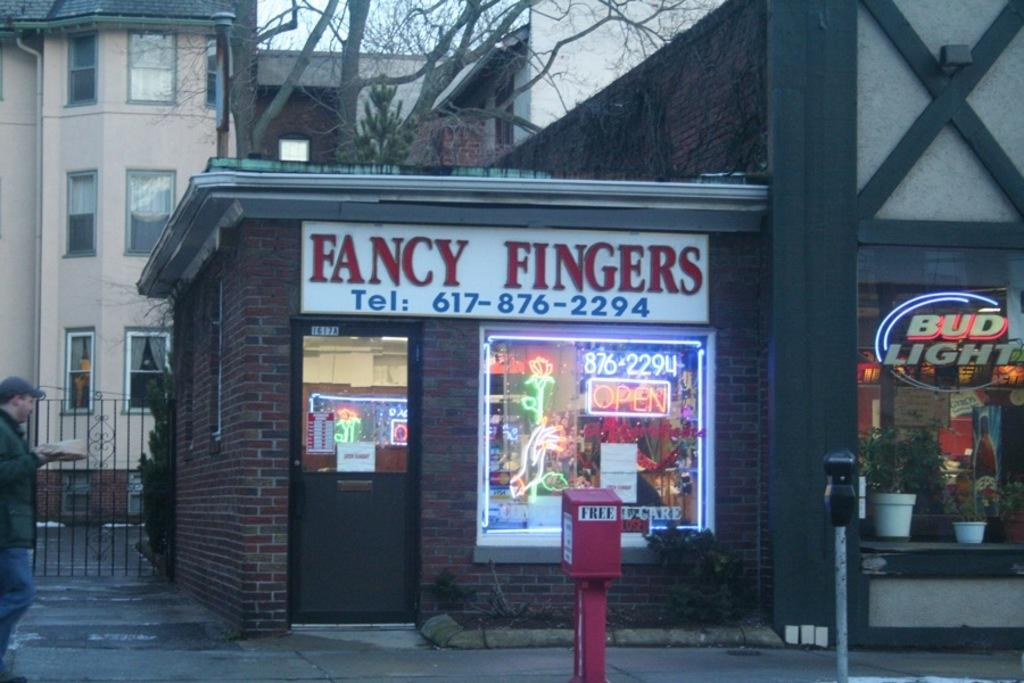<image>
Present a compact description of the photo's key features. A restaurant, called Fancy Fingers, can be reached by phone at 617-876-2294. 